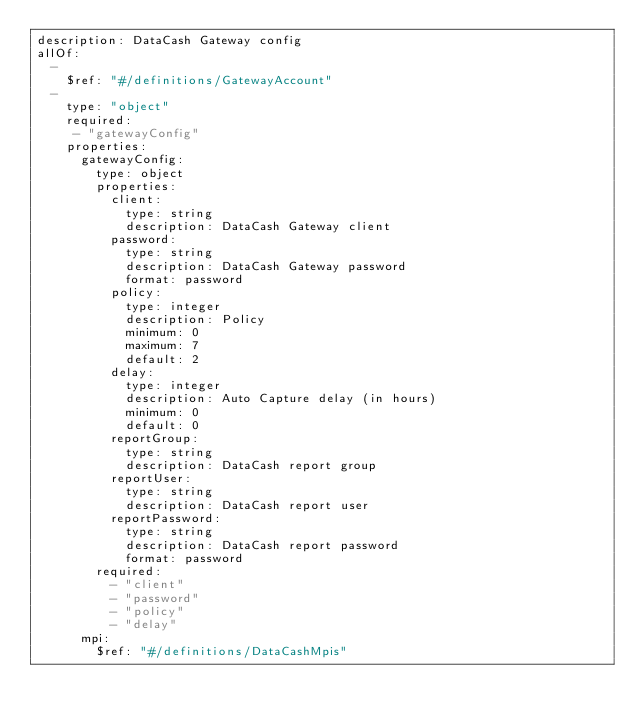Convert code to text. <code><loc_0><loc_0><loc_500><loc_500><_YAML_>description: DataCash Gateway config
allOf:
  -
    $ref: "#/definitions/GatewayAccount"
  -
    type: "object"
    required:
     - "gatewayConfig"
    properties:
      gatewayConfig:
        type: object
        properties:
          client:
            type: string
            description: DataCash Gateway client
          password:
            type: string
            description: DataCash Gateway password
            format: password
          policy:
            type: integer
            description: Policy
            minimum: 0
            maximum: 7
            default: 2
          delay:
            type: integer
            description: Auto Capture delay (in hours)
            minimum: 0
            default: 0
          reportGroup:
            type: string
            description: DataCash report group
          reportUser:
            type: string
            description: DataCash report user
          reportPassword:
            type: string
            description: DataCash report password
            format: password
        required:
          - "client"
          - "password"
          - "policy"
          - "delay"
      mpi:
        $ref: "#/definitions/DataCashMpis"
</code> 